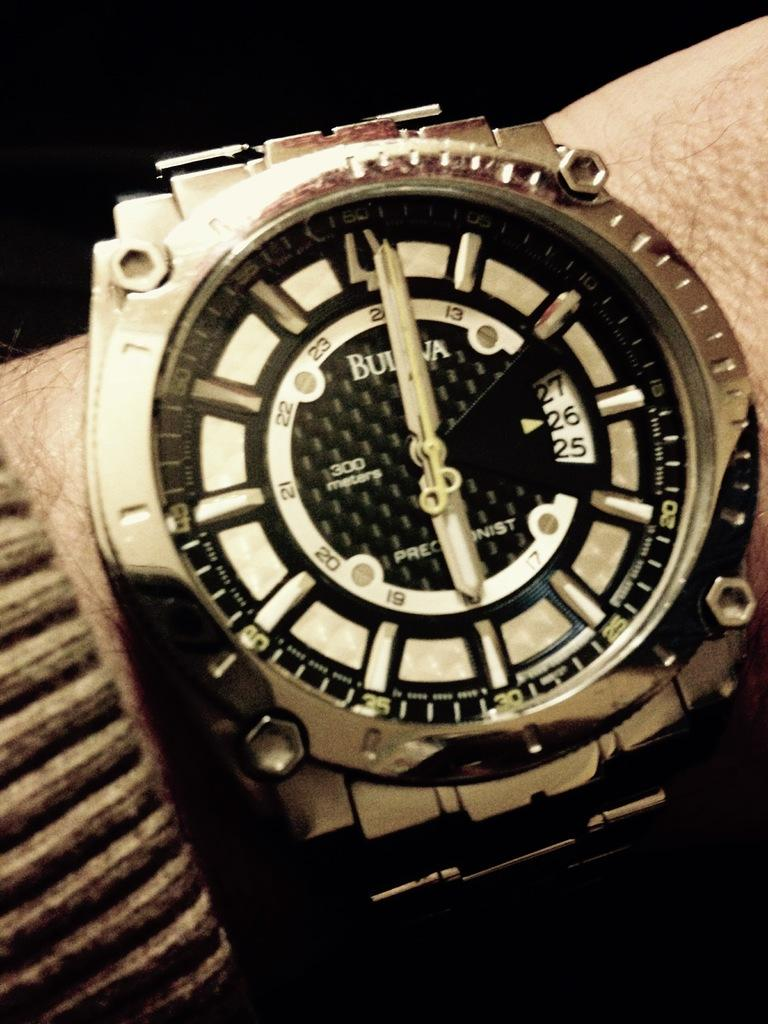<image>
Offer a succinct explanation of the picture presented. A Bulova watch has the date set to the 26th. 